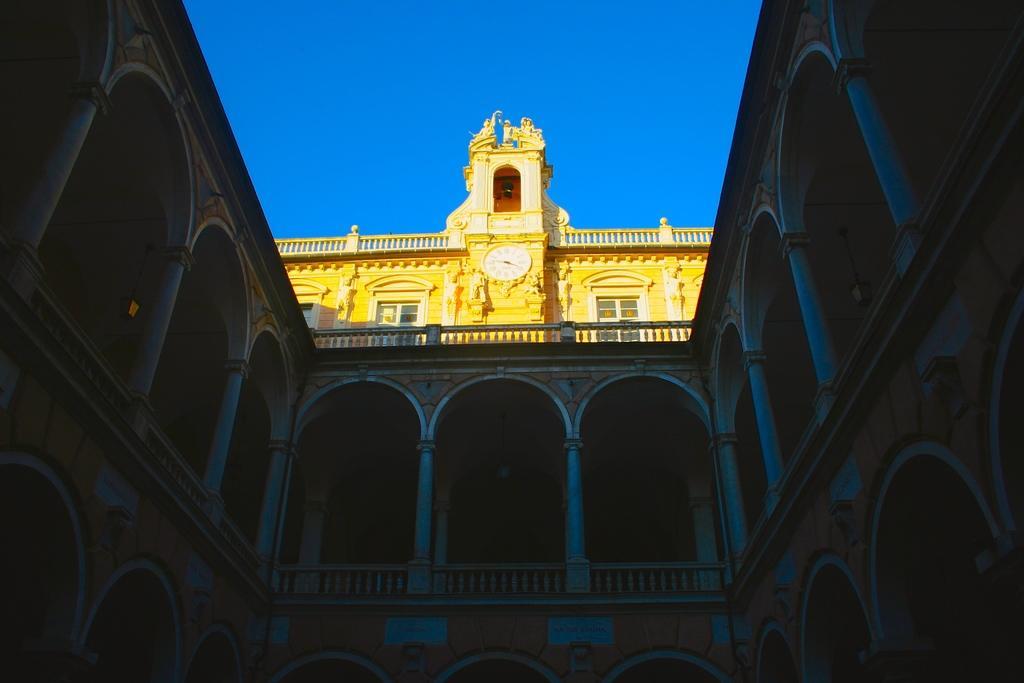How would you summarize this image in a sentence or two? In this picture I can see there is a interior of a building and it has multiple floors and there are lights attached to the ceiling and there is a tower here and there is a clock on the tower. There are few windows and the sky is clear. 